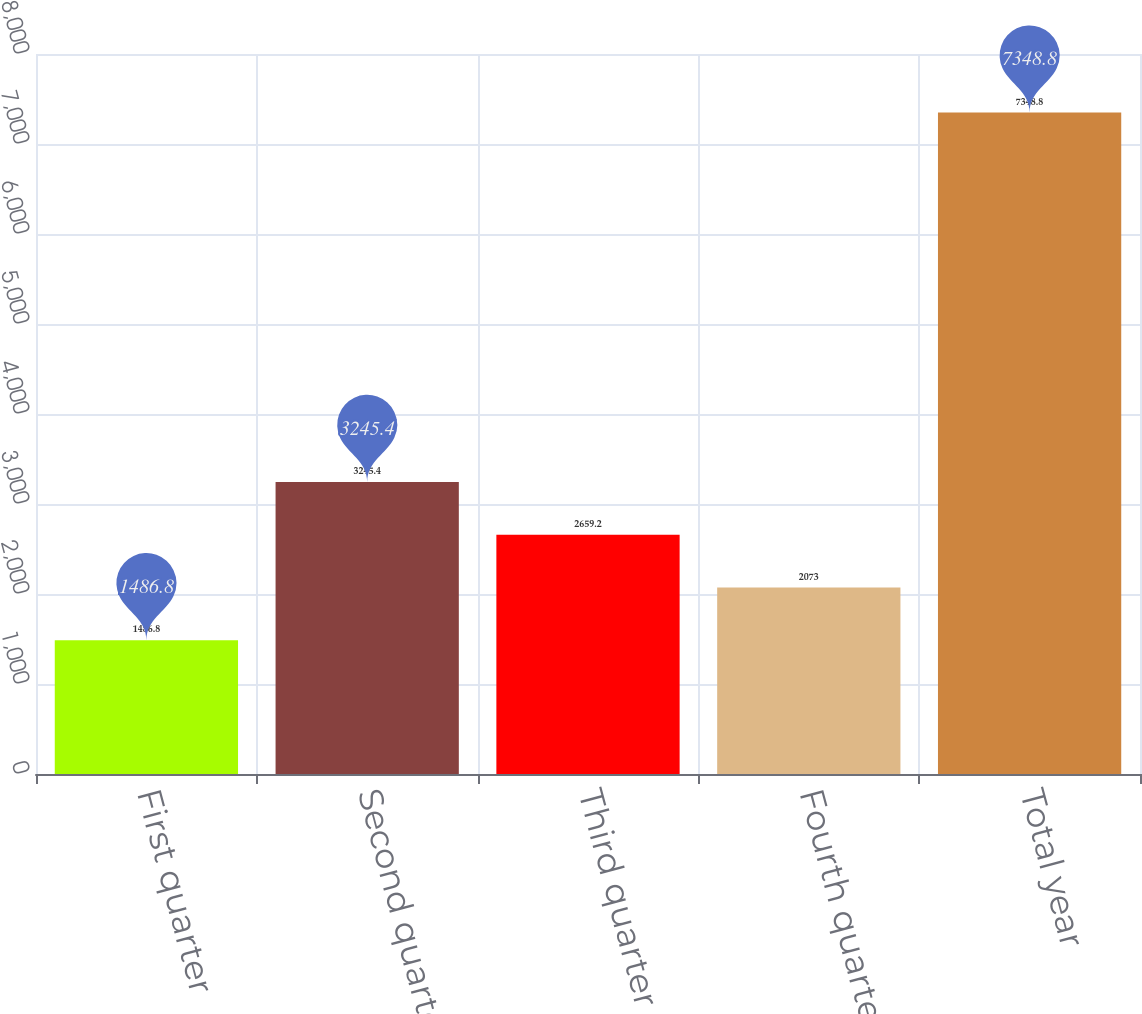Convert chart. <chart><loc_0><loc_0><loc_500><loc_500><bar_chart><fcel>First quarter<fcel>Second quarter<fcel>Third quarter<fcel>Fourth quarter<fcel>Total year<nl><fcel>1486.8<fcel>3245.4<fcel>2659.2<fcel>2073<fcel>7348.8<nl></chart> 